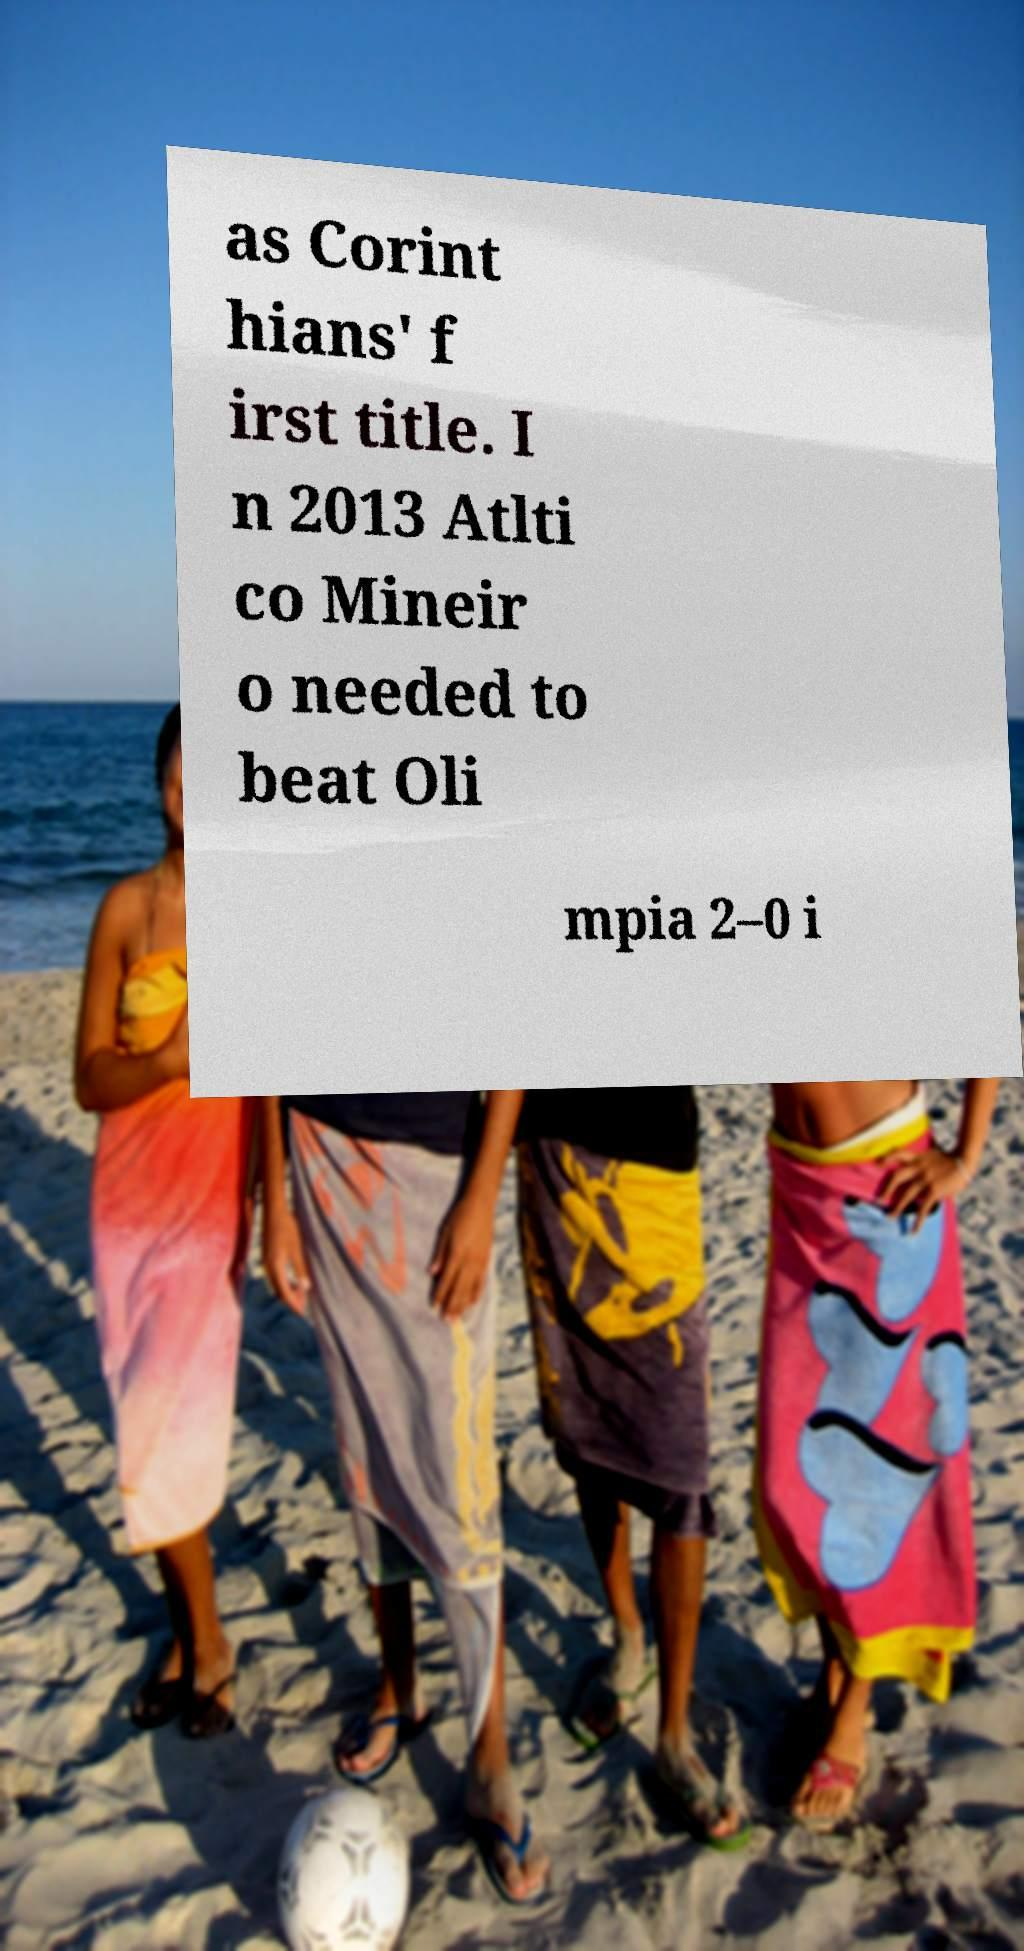There's text embedded in this image that I need extracted. Can you transcribe it verbatim? as Corint hians' f irst title. I n 2013 Atlti co Mineir o needed to beat Oli mpia 2–0 i 